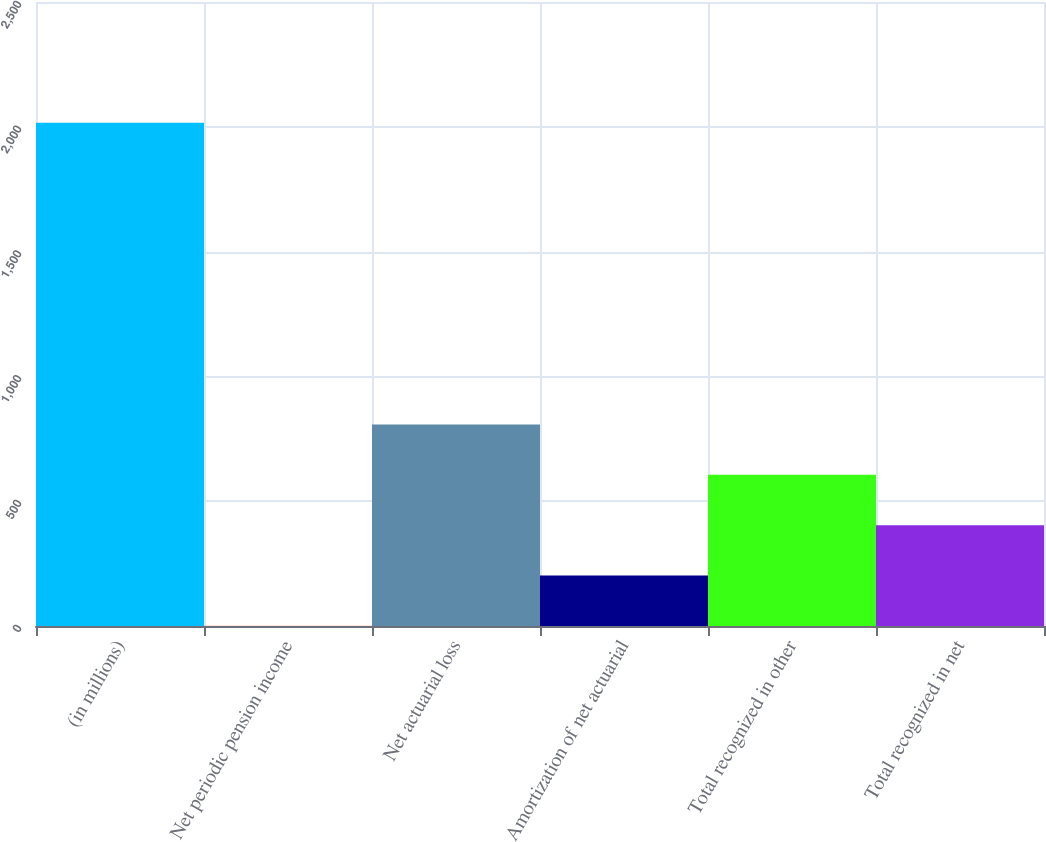<chart> <loc_0><loc_0><loc_500><loc_500><bar_chart><fcel>(in millions)<fcel>Net periodic pension income<fcel>Net actuarial loss<fcel>Amortization of net actuarial<fcel>Total recognized in other<fcel>Total recognized in net<nl><fcel>2016<fcel>1<fcel>807<fcel>202.5<fcel>605.5<fcel>404<nl></chart> 